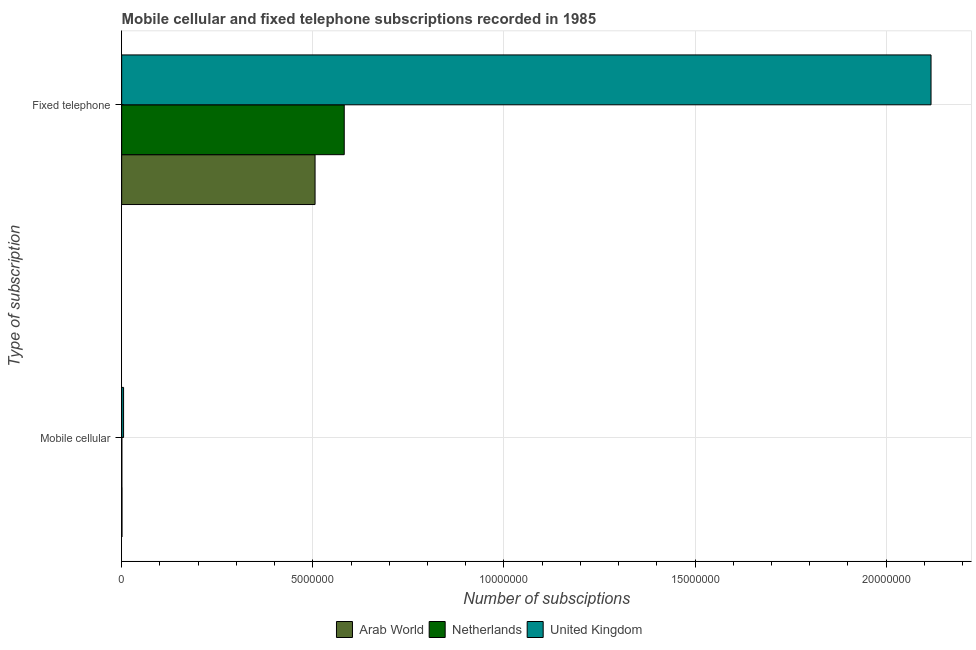How many different coloured bars are there?
Ensure brevity in your answer.  3. Are the number of bars on each tick of the Y-axis equal?
Your answer should be very brief. Yes. How many bars are there on the 1st tick from the top?
Your response must be concise. 3. What is the label of the 2nd group of bars from the top?
Offer a terse response. Mobile cellular. What is the number of mobile cellular subscriptions in Netherlands?
Give a very brief answer. 4800. Across all countries, what is the maximum number of mobile cellular subscriptions?
Your answer should be very brief. 5.00e+04. Across all countries, what is the minimum number of fixed telephone subscriptions?
Offer a terse response. 5.06e+06. In which country was the number of fixed telephone subscriptions minimum?
Offer a very short reply. Arab World. What is the total number of fixed telephone subscriptions in the graph?
Give a very brief answer. 3.21e+07. What is the difference between the number of mobile cellular subscriptions in Netherlands and that in United Kingdom?
Offer a very short reply. -4.52e+04. What is the difference between the number of mobile cellular subscriptions in Arab World and the number of fixed telephone subscriptions in Netherlands?
Offer a terse response. -5.82e+06. What is the average number of mobile cellular subscriptions per country?
Offer a terse response. 2.09e+04. What is the difference between the number of mobile cellular subscriptions and number of fixed telephone subscriptions in Netherlands?
Your response must be concise. -5.82e+06. What is the ratio of the number of fixed telephone subscriptions in Arab World to that in United Kingdom?
Offer a very short reply. 0.24. Is the number of mobile cellular subscriptions in Arab World less than that in United Kingdom?
Provide a short and direct response. Yes. How many bars are there?
Offer a terse response. 6. How many countries are there in the graph?
Provide a succinct answer. 3. Does the graph contain any zero values?
Give a very brief answer. No. How many legend labels are there?
Ensure brevity in your answer.  3. What is the title of the graph?
Ensure brevity in your answer.  Mobile cellular and fixed telephone subscriptions recorded in 1985. What is the label or title of the X-axis?
Your answer should be compact. Number of subsciptions. What is the label or title of the Y-axis?
Provide a short and direct response. Type of subscription. What is the Number of subsciptions of Arab World in Mobile cellular?
Provide a short and direct response. 7976. What is the Number of subsciptions of Netherlands in Mobile cellular?
Your response must be concise. 4800. What is the Number of subsciptions of United Kingdom in Mobile cellular?
Your answer should be compact. 5.00e+04. What is the Number of subsciptions in Arab World in Fixed telephone?
Give a very brief answer. 5.06e+06. What is the Number of subsciptions of Netherlands in Fixed telephone?
Keep it short and to the point. 5.82e+06. What is the Number of subsciptions in United Kingdom in Fixed telephone?
Offer a terse response. 2.12e+07. Across all Type of subscription, what is the maximum Number of subsciptions of Arab World?
Offer a very short reply. 5.06e+06. Across all Type of subscription, what is the maximum Number of subsciptions of Netherlands?
Make the answer very short. 5.82e+06. Across all Type of subscription, what is the maximum Number of subsciptions of United Kingdom?
Offer a very short reply. 2.12e+07. Across all Type of subscription, what is the minimum Number of subsciptions of Arab World?
Ensure brevity in your answer.  7976. Across all Type of subscription, what is the minimum Number of subsciptions of Netherlands?
Provide a short and direct response. 4800. Across all Type of subscription, what is the minimum Number of subsciptions in United Kingdom?
Provide a short and direct response. 5.00e+04. What is the total Number of subsciptions of Arab World in the graph?
Give a very brief answer. 5.07e+06. What is the total Number of subsciptions of Netherlands in the graph?
Your response must be concise. 5.83e+06. What is the total Number of subsciptions in United Kingdom in the graph?
Make the answer very short. 2.12e+07. What is the difference between the Number of subsciptions in Arab World in Mobile cellular and that in Fixed telephone?
Provide a succinct answer. -5.05e+06. What is the difference between the Number of subsciptions in Netherlands in Mobile cellular and that in Fixed telephone?
Your answer should be compact. -5.82e+06. What is the difference between the Number of subsciptions of United Kingdom in Mobile cellular and that in Fixed telephone?
Provide a short and direct response. -2.11e+07. What is the difference between the Number of subsciptions of Arab World in Mobile cellular and the Number of subsciptions of Netherlands in Fixed telephone?
Offer a very short reply. -5.82e+06. What is the difference between the Number of subsciptions of Arab World in Mobile cellular and the Number of subsciptions of United Kingdom in Fixed telephone?
Your answer should be compact. -2.12e+07. What is the difference between the Number of subsciptions in Netherlands in Mobile cellular and the Number of subsciptions in United Kingdom in Fixed telephone?
Give a very brief answer. -2.12e+07. What is the average Number of subsciptions of Arab World per Type of subscription?
Your answer should be compact. 2.53e+06. What is the average Number of subsciptions in Netherlands per Type of subscription?
Give a very brief answer. 2.91e+06. What is the average Number of subsciptions in United Kingdom per Type of subscription?
Your answer should be very brief. 1.06e+07. What is the difference between the Number of subsciptions in Arab World and Number of subsciptions in Netherlands in Mobile cellular?
Keep it short and to the point. 3176. What is the difference between the Number of subsciptions in Arab World and Number of subsciptions in United Kingdom in Mobile cellular?
Ensure brevity in your answer.  -4.20e+04. What is the difference between the Number of subsciptions in Netherlands and Number of subsciptions in United Kingdom in Mobile cellular?
Give a very brief answer. -4.52e+04. What is the difference between the Number of subsciptions of Arab World and Number of subsciptions of Netherlands in Fixed telephone?
Give a very brief answer. -7.63e+05. What is the difference between the Number of subsciptions in Arab World and Number of subsciptions in United Kingdom in Fixed telephone?
Provide a short and direct response. -1.61e+07. What is the difference between the Number of subsciptions in Netherlands and Number of subsciptions in United Kingdom in Fixed telephone?
Your answer should be compact. -1.54e+07. What is the ratio of the Number of subsciptions of Arab World in Mobile cellular to that in Fixed telephone?
Provide a short and direct response. 0. What is the ratio of the Number of subsciptions in Netherlands in Mobile cellular to that in Fixed telephone?
Offer a very short reply. 0. What is the ratio of the Number of subsciptions of United Kingdom in Mobile cellular to that in Fixed telephone?
Offer a very short reply. 0. What is the difference between the highest and the second highest Number of subsciptions of Arab World?
Your response must be concise. 5.05e+06. What is the difference between the highest and the second highest Number of subsciptions of Netherlands?
Offer a terse response. 5.82e+06. What is the difference between the highest and the second highest Number of subsciptions of United Kingdom?
Make the answer very short. 2.11e+07. What is the difference between the highest and the lowest Number of subsciptions of Arab World?
Keep it short and to the point. 5.05e+06. What is the difference between the highest and the lowest Number of subsciptions in Netherlands?
Offer a terse response. 5.82e+06. What is the difference between the highest and the lowest Number of subsciptions in United Kingdom?
Provide a succinct answer. 2.11e+07. 